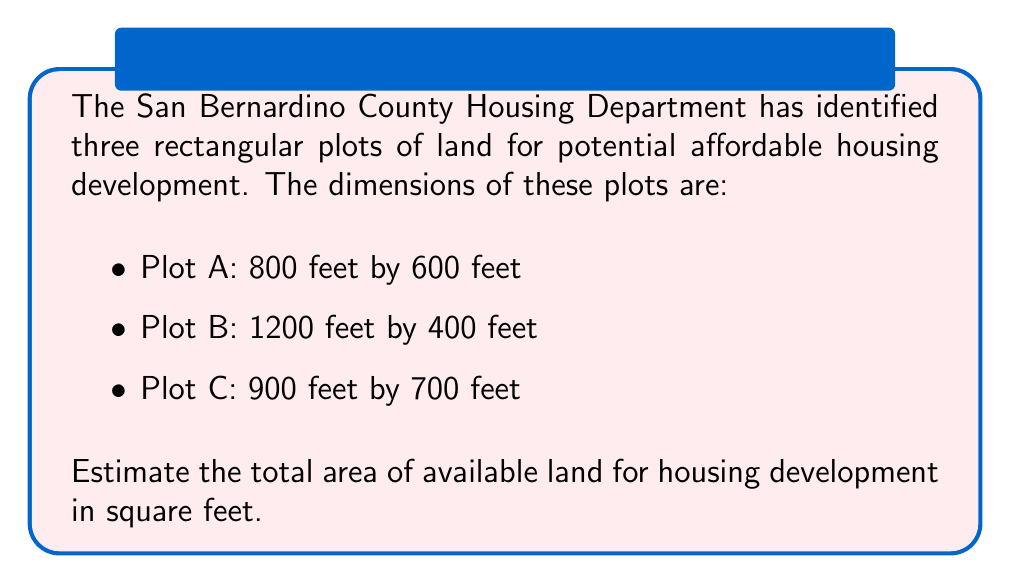Solve this math problem. To solve this problem, we need to calculate the area of each rectangular plot and then sum them up. Let's go through it step-by-step:

1. Calculate the area of Plot A:
   $A_A = l_A \times w_A = 800 \text{ ft} \times 600 \text{ ft} = 480,000 \text{ sq ft}$

2. Calculate the area of Plot B:
   $A_B = l_B \times w_B = 1200 \text{ ft} \times 400 \text{ ft} = 480,000 \text{ sq ft}$

3. Calculate the area of Plot C:
   $A_C = l_C \times w_C = 900 \text{ ft} \times 700 \text{ ft} = 630,000 \text{ sq ft}$

4. Sum up the areas of all three plots:
   $$\begin{align}
   A_{total} &= A_A + A_B + A_C \\
   &= 480,000 \text{ sq ft} + 480,000 \text{ sq ft} + 630,000 \text{ sq ft} \\
   &= 1,590,000 \text{ sq ft}
   \end{align}$$

Therefore, the total area of available land for housing development is 1,590,000 square feet.
Answer: 1,590,000 sq ft 